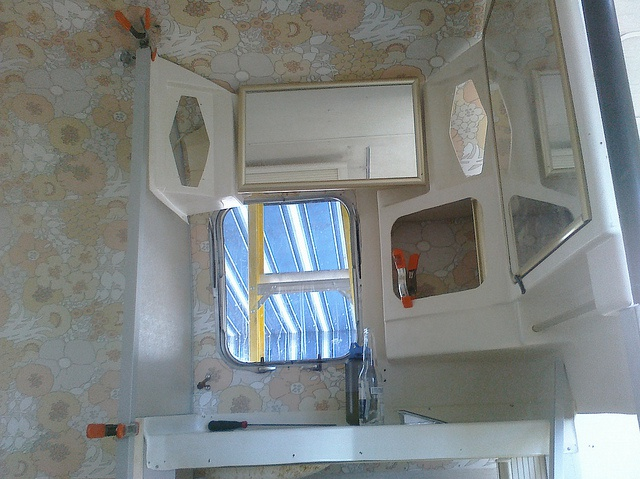Describe the objects in this image and their specific colors. I can see sink in gray and darkgray tones, bottle in gray and blue tones, and bottle in gray, black, blue, and navy tones in this image. 